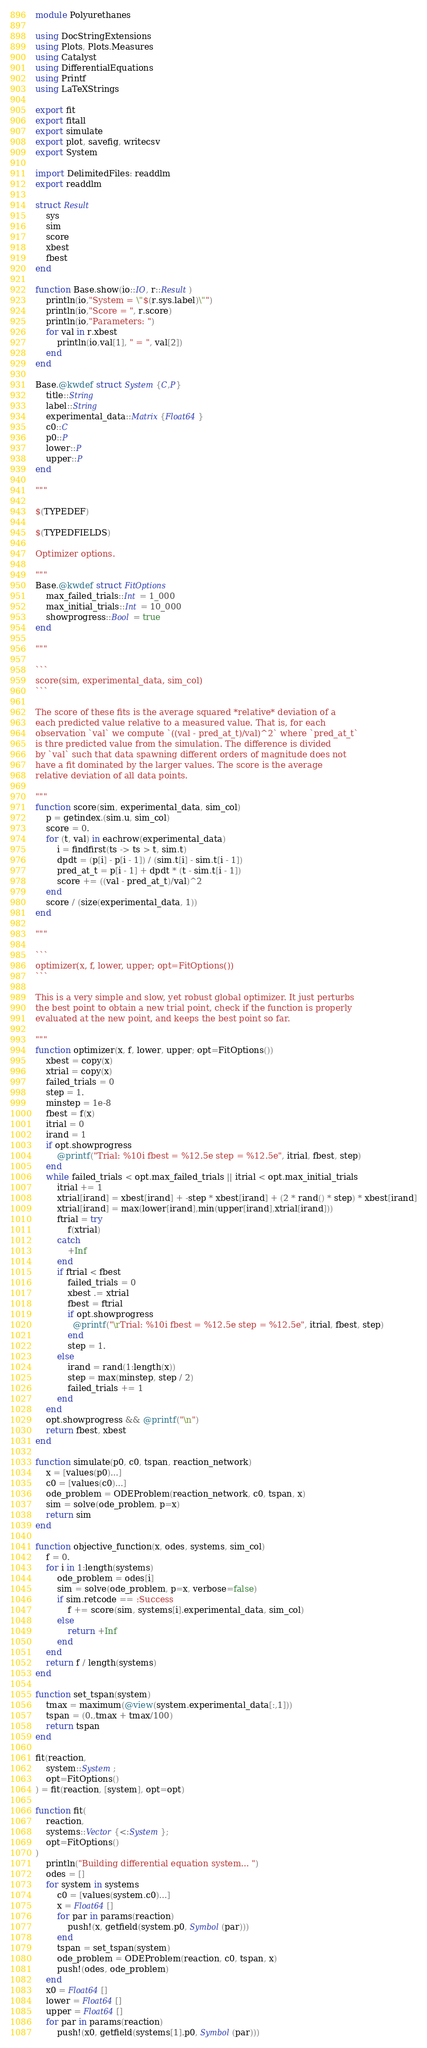<code> <loc_0><loc_0><loc_500><loc_500><_Julia_>module Polyurethanes

using DocStringExtensions
using Plots, Plots.Measures
using Catalyst
using DifferentialEquations
using Printf
using LaTeXStrings

export fit
export fitall
export simulate
export plot, savefig, writecsv
export System

import DelimitedFiles: readdlm
export readdlm

struct Result
    sys
    sim
    score
    xbest
    fbest
end

function Base.show(io::IO, r::Result)
    println(io,"System = \"$(r.sys.label)\"")
    println(io,"Score = ", r.score)
    println(io,"Parameters: ")
    for val in r.xbest
        println(io,val[1], " = ", val[2])
    end
end

Base.@kwdef struct System{C,P}
    title::String
    label::String
    experimental_data::Matrix{Float64}
    c0::C
    p0::P
    lower::P
    upper::P
end

"""

$(TYPEDEF)

$(TYPEDFIELDS)

Optimizer options.

"""
Base.@kwdef struct FitOptions
    max_failed_trials::Int = 1_000
    max_initial_trials::Int = 10_000
    showprogress::Bool = true
end

"""

```
score(sim, experimental_data, sim_col)
```

The score of these fits is the average squared *relative* deviation of a 
each predicted value relative to a measured value. That is, for each 
observation `val` we compute `((val - pred_at_t)/val)^2` where `pred_at_t`
is thre predicted value from the simulation. The difference is divided 
by `val` such that data spawning different orders of magnitude does not
have a fit dominated by the larger values. The score is the average
relative deviation of all data points. 

"""
function score(sim, experimental_data, sim_col)
    p = getindex.(sim.u, sim_col)
    score = 0.
    for (t, val) in eachrow(experimental_data)
        i = findfirst(ts -> ts > t, sim.t)
        dpdt = (p[i] - p[i - 1]) / (sim.t[i] - sim.t[i - 1])
        pred_at_t = p[i - 1] + dpdt * (t - sim.t[i - 1]) 
        score += ((val - pred_at_t)/val)^2
    end
    score / (size(experimental_data, 1))
end

"""

```
optimizer(x, f, lower, upper; opt=FitOptions())
```

This is a very simple and slow, yet robust global optimizer. It just perturbs
the best point to obtain a new trial point, check if the function is properly
evaluated at the new point, and keeps the best point so far. 

"""
function optimizer(x, f, lower, upper; opt=FitOptions())
    xbest = copy(x)
    xtrial = copy(x)
    failed_trials = 0
    step = 1.
    minstep = 1e-8
    fbest = f(x)
    itrial = 0
    irand = 1
    if opt.showprogress
        @printf("Trial: %10i fbest = %12.5e step = %12.5e", itrial, fbest, step)
    end
    while failed_trials < opt.max_failed_trials || itrial < opt.max_initial_trials
        itrial += 1
        xtrial[irand] = xbest[irand] + -step * xbest[irand] + (2 * rand() * step) * xbest[irand]
        xtrial[irand] = max(lower[irand],min(upper[irand],xtrial[irand]))
        ftrial = try 
            f(xtrial)
        catch
            +Inf
        end
        if ftrial < fbest
            failed_trials = 0
            xbest .= xtrial
            fbest = ftrial
            if opt.showprogress
              @printf("\rTrial: %10i fbest = %12.5e step = %12.5e", itrial, fbest, step)
            end
            step = 1.
        else 
            irand = rand(1:length(x))
            step = max(minstep, step / 2)
            failed_trials += 1
        end
    end
    opt.showprogress && @printf("\n")
    return fbest, xbest
end

function simulate(p0, c0, tspan, reaction_network)
    x = [values(p0)...]
    c0 = [values(c0)...]
    ode_problem = ODEProblem(reaction_network, c0, tspan, x)
    sim = solve(ode_problem, p=x)
    return sim
end

function objective_function(x, odes, systems, sim_col)
    f = 0.
    for i in 1:length(systems)
        ode_problem = odes[i]
        sim = solve(ode_problem, p=x, verbose=false)
        if sim.retcode == :Success
            f += score(sim, systems[i].experimental_data, sim_col)
        else
            return +Inf
        end
    end
    return f / length(systems)
end

function set_tspan(system)
    tmax = maximum(@view(system.experimental_data[:,1]))
    tspan = (0.,tmax + tmax/100)
    return tspan
end

fit(reaction, 
    system::System;
    opt=FitOptions()
) = fit(reaction, [system], opt=opt)

function fit(
    reaction,
    systems::Vector{<:System};
    opt=FitOptions()
)
    println("Building differential equation system... ")
    odes = []
    for system in systems
        c0 = [values(system.c0)...]
        x = Float64[]
        for par in params(reaction)
            push!(x, getfield(system.p0, Symbol(par)))
        end
        tspan = set_tspan(system)
        ode_problem = ODEProblem(reaction, c0, tspan, x)
        push!(odes, ode_problem)
    end
    x0 = Float64[]
    lower = Float64[]
    upper = Float64[]
    for par in params(reaction)
        push!(x0, getfield(systems[1].p0, Symbol(par)))</code> 